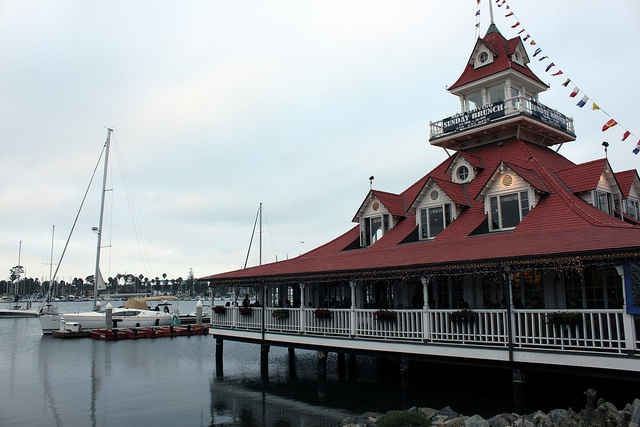Describe the objects in this image and their specific colors. I can see boat in white, darkgray, gray, and lightgray tones, boat in white, black, gray, maroon, and purple tones, potted plant in black, gray, and white tones, boat in white, black, gray, darkgray, and lightgray tones, and potted plant in white, black, gray, and darkgreen tones in this image. 